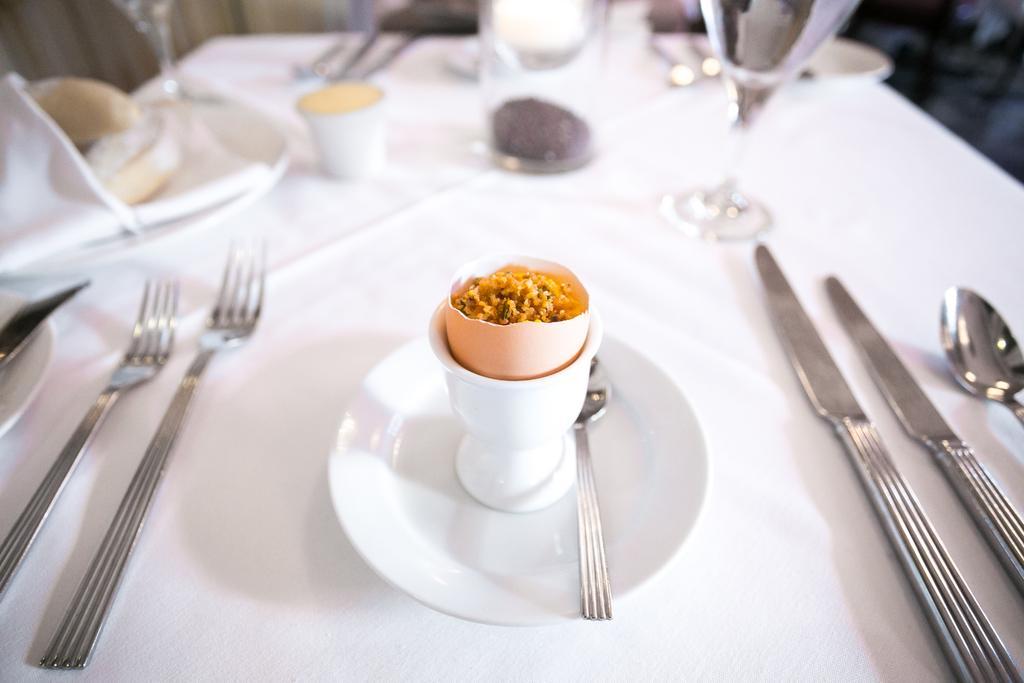Describe this image in one or two sentences. In this image i can see a table on which there are few plates, few forks, few spoons, few knives , few cups and food items. 